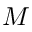<formula> <loc_0><loc_0><loc_500><loc_500>M</formula> 